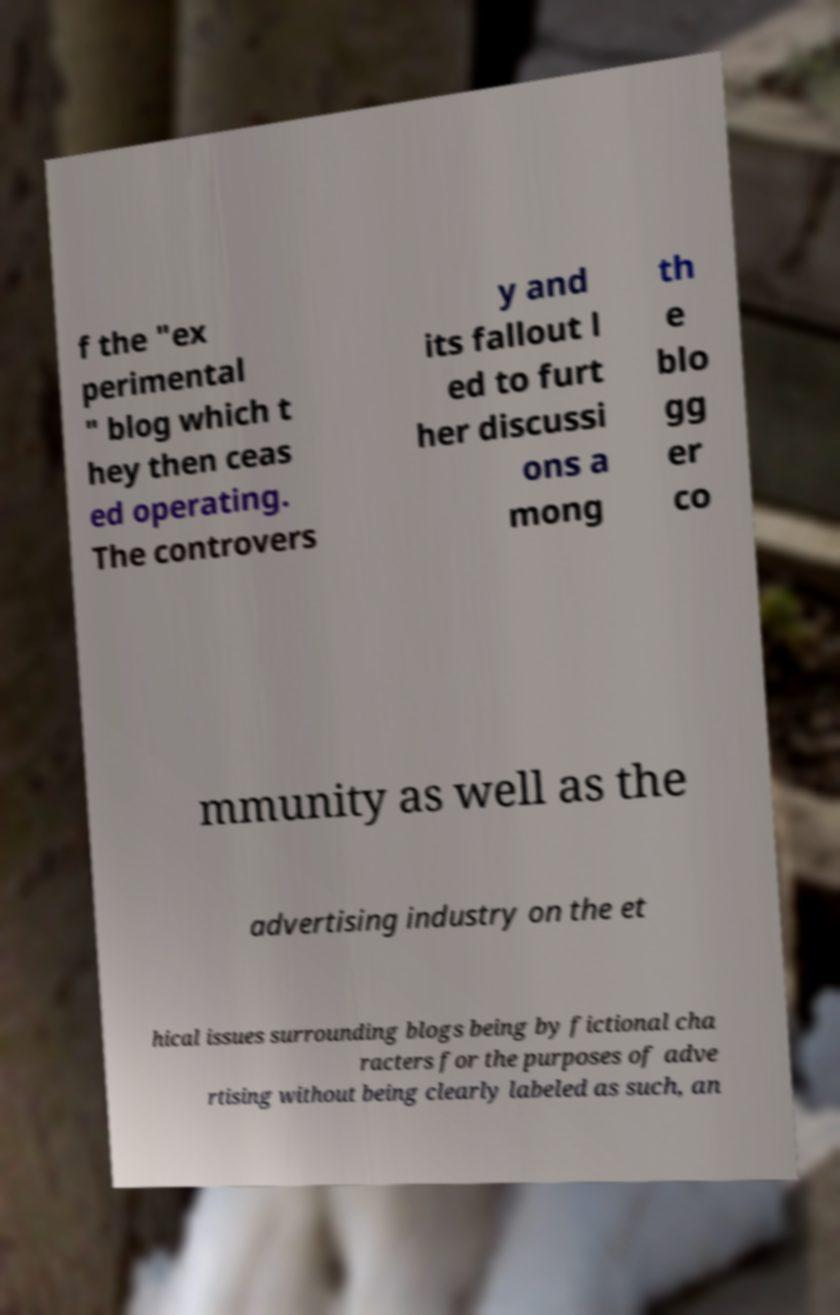Can you accurately transcribe the text from the provided image for me? f the "ex perimental " blog which t hey then ceas ed operating. The controvers y and its fallout l ed to furt her discussi ons a mong th e blo gg er co mmunity as well as the advertising industry on the et hical issues surrounding blogs being by fictional cha racters for the purposes of adve rtising without being clearly labeled as such, an 